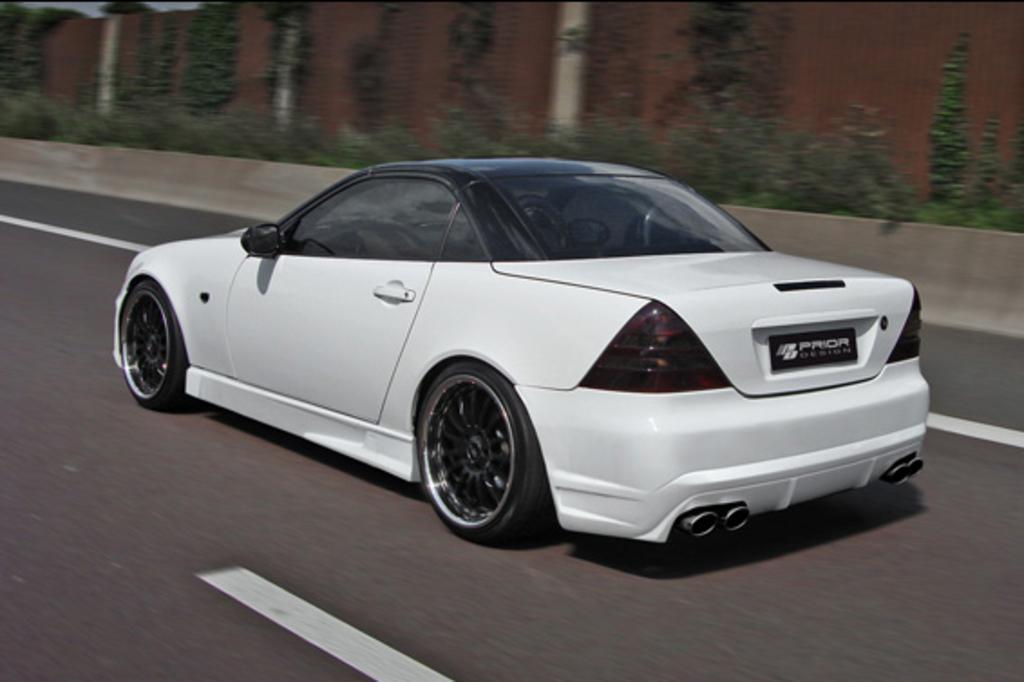In one or two sentences, can you explain what this image depicts? In this picture I can observe a car in the middle of the picture. In the background I can observe plants and wall. 